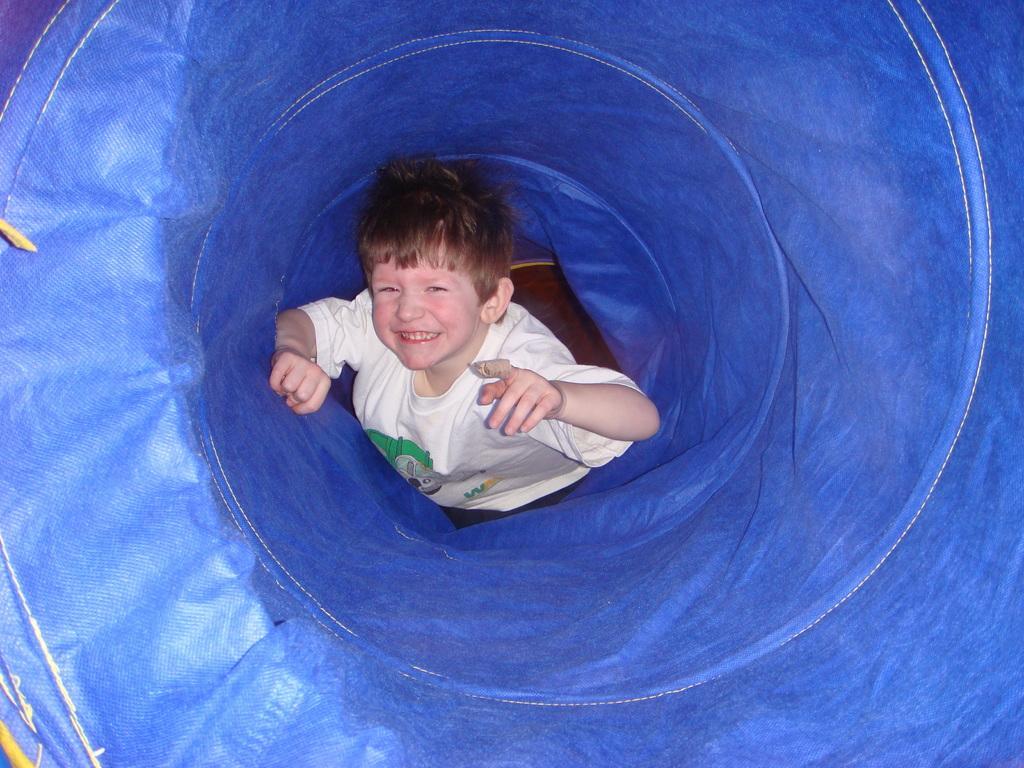Please provide a concise description of this image. In this image I can see a boy wearing a white color t-shirt and he is visible on blue color container. 